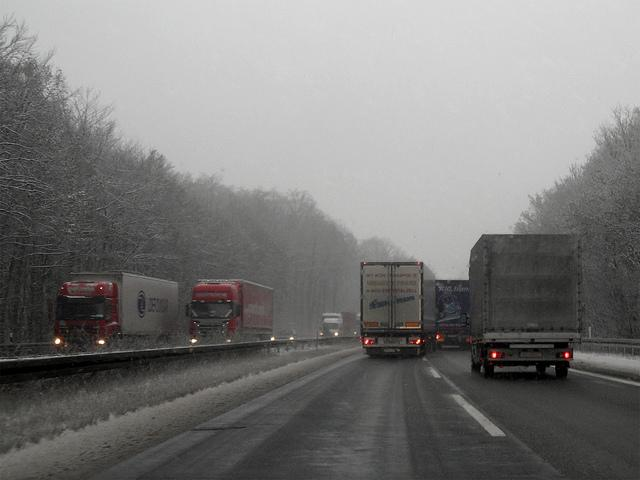What is blowing in the wind?

Choices:
A) sand
B) leaves
C) rain
D) snow snow 